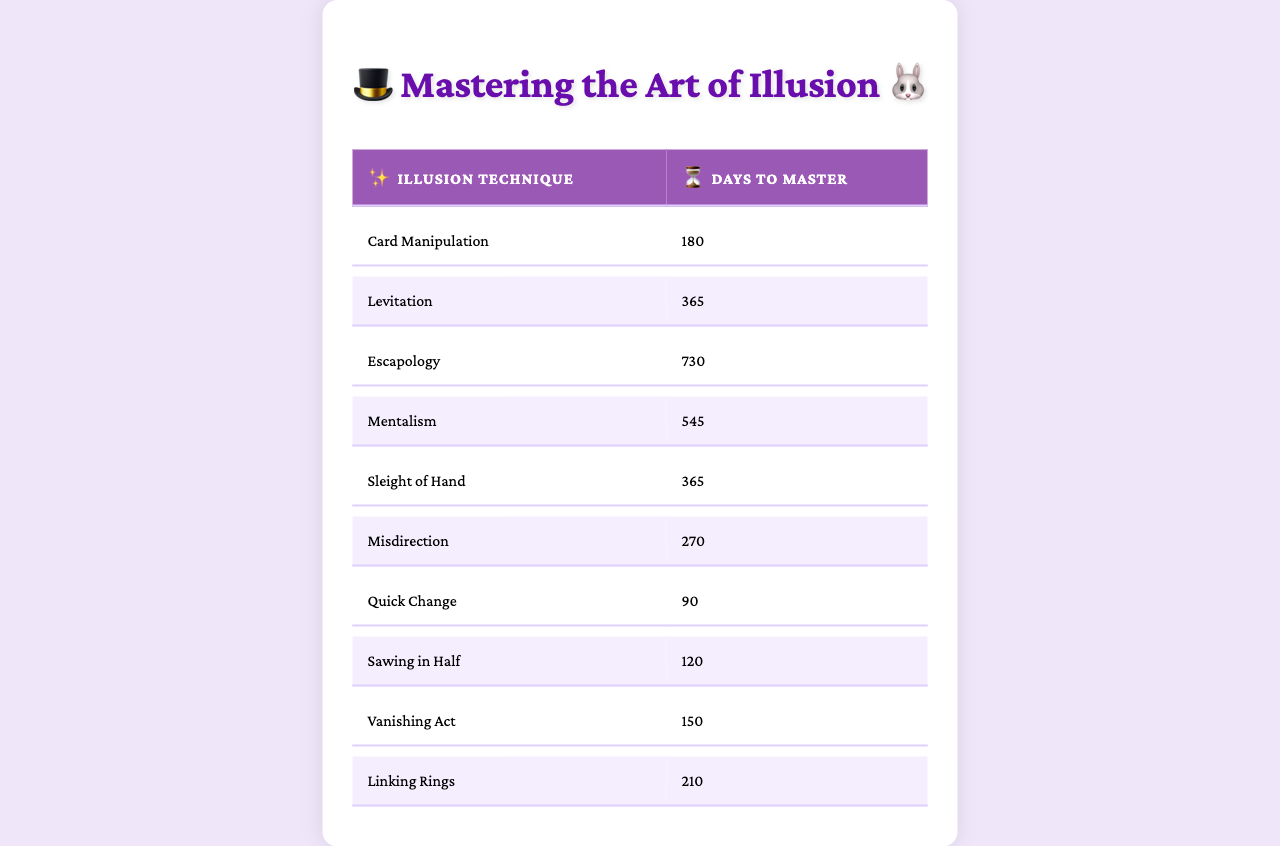What is the technique that takes the longest time to master? Looking at the table, "Escapology" has the longest time to master with 730 days.
Answer: Escapology How many days does it take to master "Vanishing Act"? Referring to the table, "Vanishing Act" takes 150 days to master.
Answer: 150 days Which technique takes the least time to master? The table shows that "Quick Change" takes the least time to master at 90 days.
Answer: Quick Change Is it true that "Sleight of Hand" and "Levitation" both require the same amount of time to master? Checking the table, "Sleight of Hand" takes 365 days while "Levitation" takes 365 days, so the statement is true.
Answer: Yes What is the total time to master "Sleight of Hand", "Card Manipulation", and "Misdirection"? Adding the days: 365 (Sleight of Hand) + 180 (Card Manipulation) + 270 (Misdirection) equals 815 days.
Answer: 815 days Which two techniques have the same time to master? The table shows that "Levitation" and "Sleight of Hand" both take 365 days to master.
Answer: Levitation and Sleight of Hand What percentage of the total mastery days does "Sawing in Half" represent? The total days to master all techniques is 3650 days. "Sawing in Half" takes 120 days. So, (120/3650) * 100 = 3.29%.
Answer: 3.29% Which technique requires more time to master, "Mentalism" or "Misdirection"? "Mentalism" takes 545 days and "Misdirection" takes 270 days, therefore "Mentalism" takes more time.
Answer: Mentalism What is the average time required to master all illusion techniques? First, sum up all days: 180 + 365 + 730 + 545 + 365 + 270 + 90 + 120 + 150 + 210 = 3650. Then, divide by the number of techniques (10): 3650 / 10 = 365 days.
Answer: 365 days How do the times to master "Linking Rings" and "Vanishing Act" compare? "Linking Rings" takes 210 days while "Vanishing Act" takes 150 days, so "Linking Rings" requires more time.
Answer: Linking Rings require more time 